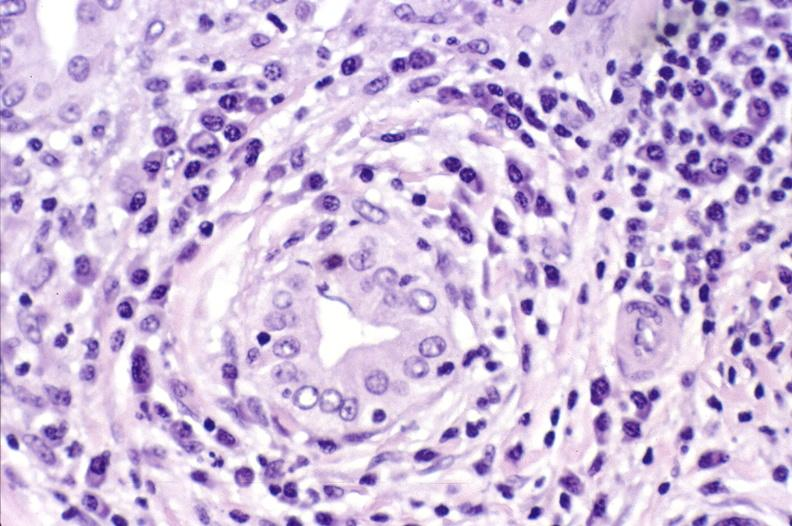s chronic lymphocytic leukemia present?
Answer the question using a single word or phrase. No 